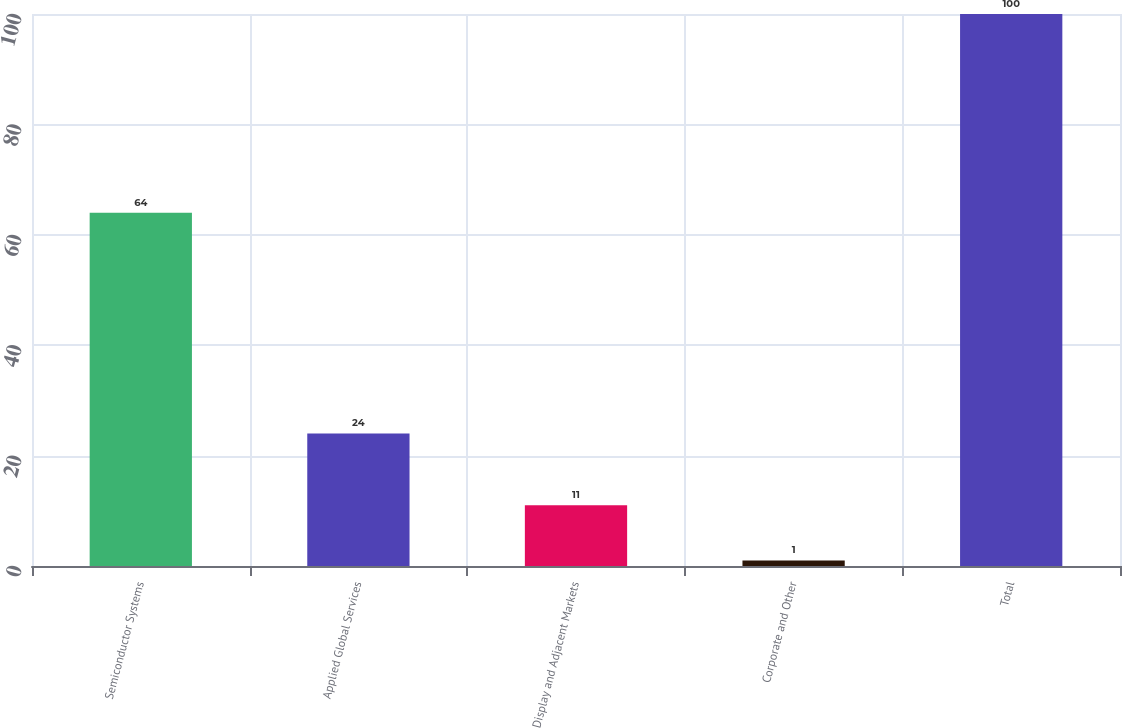<chart> <loc_0><loc_0><loc_500><loc_500><bar_chart><fcel>Semiconductor Systems<fcel>Applied Global Services<fcel>Display and Adjacent Markets<fcel>Corporate and Other<fcel>Total<nl><fcel>64<fcel>24<fcel>11<fcel>1<fcel>100<nl></chart> 